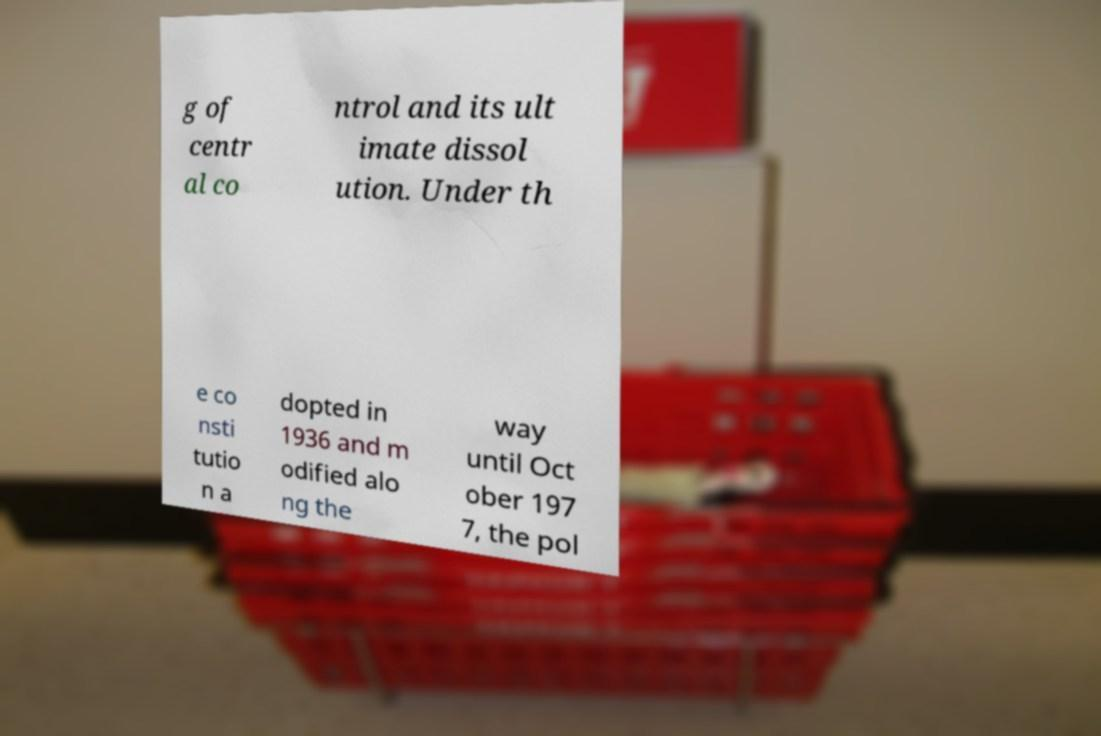What messages or text are displayed in this image? I need them in a readable, typed format. g of centr al co ntrol and its ult imate dissol ution. Under th e co nsti tutio n a dopted in 1936 and m odified alo ng the way until Oct ober 197 7, the pol 